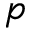<formula> <loc_0><loc_0><loc_500><loc_500>p</formula> 